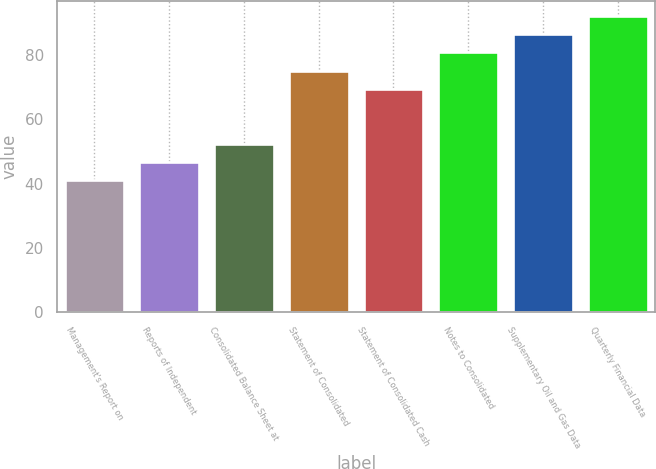Convert chart. <chart><loc_0><loc_0><loc_500><loc_500><bar_chart><fcel>Management's Report on<fcel>Reports of Independent<fcel>Consolidated Balance Sheet at<fcel>Statement of Consolidated<fcel>Statement of Consolidated Cash<fcel>Notes to Consolidated<fcel>Supplementary Oil and Gas Data<fcel>Quarterly Financial Data<nl><fcel>41<fcel>46.7<fcel>52.4<fcel>75.2<fcel>69.5<fcel>80.9<fcel>86.6<fcel>92.3<nl></chart> 